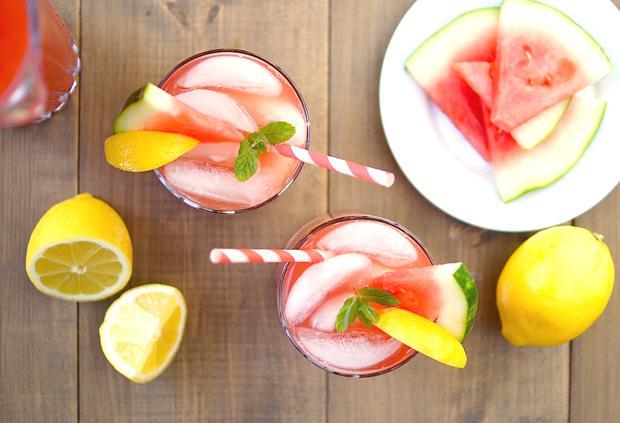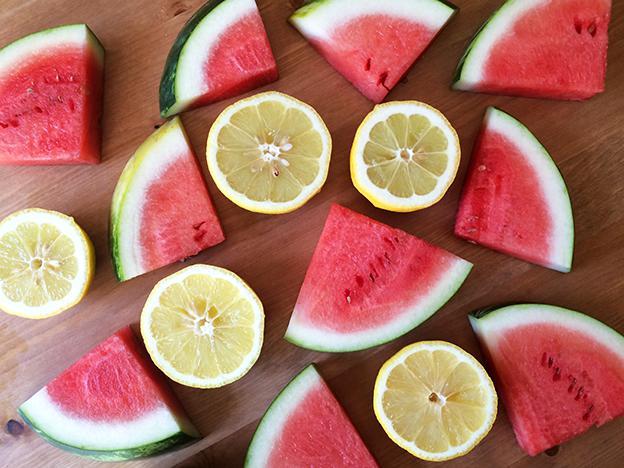The first image is the image on the left, the second image is the image on the right. Given the left and right images, does the statement "In one image, glasses are garnished with lemon pieces." hold true? Answer yes or no. Yes. 